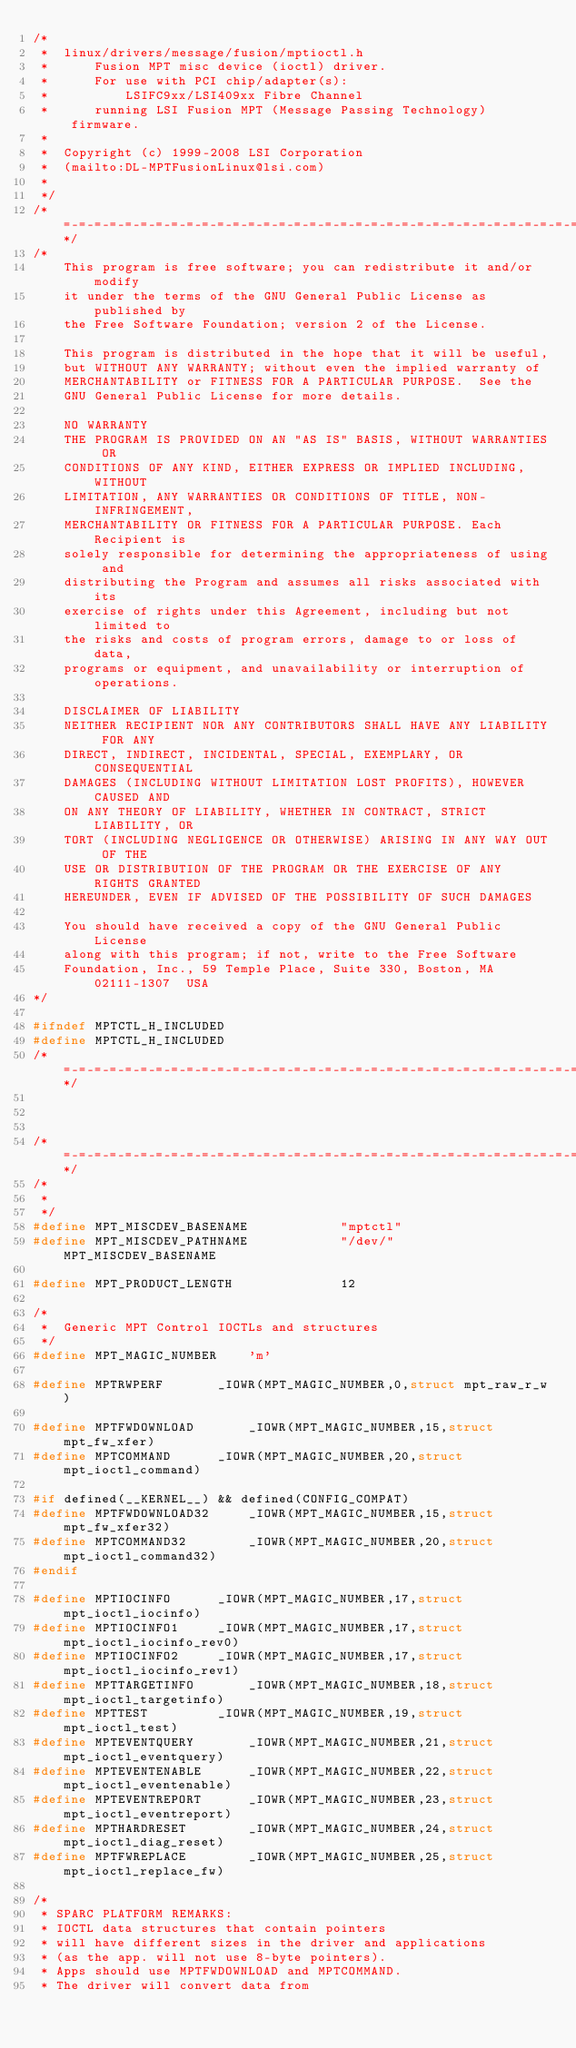<code> <loc_0><loc_0><loc_500><loc_500><_C_>/*
 *  linux/drivers/message/fusion/mptioctl.h
 *      Fusion MPT misc device (ioctl) driver.
 *      For use with PCI chip/adapter(s):
 *          LSIFC9xx/LSI409xx Fibre Channel
 *      running LSI Fusion MPT (Message Passing Technology) firmware.
 *
 *  Copyright (c) 1999-2008 LSI Corporation
 *  (mailto:DL-MPTFusionLinux@lsi.com)
 *
 */
/*=-=-=-=-=-=-=-=-=-=-=-=-=-=-=-=-=-=-=-=-=-=-=-=-=-=-=-=-=-=-=-=-=-=-=-=-=-=*/
/*
    This program is free software; you can redistribute it and/or modify
    it under the terms of the GNU General Public License as published by
    the Free Software Foundation; version 2 of the License.

    This program is distributed in the hope that it will be useful,
    but WITHOUT ANY WARRANTY; without even the implied warranty of
    MERCHANTABILITY or FITNESS FOR A PARTICULAR PURPOSE.  See the
    GNU General Public License for more details.

    NO WARRANTY
    THE PROGRAM IS PROVIDED ON AN "AS IS" BASIS, WITHOUT WARRANTIES OR
    CONDITIONS OF ANY KIND, EITHER EXPRESS OR IMPLIED INCLUDING, WITHOUT
    LIMITATION, ANY WARRANTIES OR CONDITIONS OF TITLE, NON-INFRINGEMENT,
    MERCHANTABILITY OR FITNESS FOR A PARTICULAR PURPOSE. Each Recipient is
    solely responsible for determining the appropriateness of using and
    distributing the Program and assumes all risks associated with its
    exercise of rights under this Agreement, including but not limited to
    the risks and costs of program errors, damage to or loss of data,
    programs or equipment, and unavailability or interruption of operations.

    DISCLAIMER OF LIABILITY
    NEITHER RECIPIENT NOR ANY CONTRIBUTORS SHALL HAVE ANY LIABILITY FOR ANY
    DIRECT, INDIRECT, INCIDENTAL, SPECIAL, EXEMPLARY, OR CONSEQUENTIAL
    DAMAGES (INCLUDING WITHOUT LIMITATION LOST PROFITS), HOWEVER CAUSED AND
    ON ANY THEORY OF LIABILITY, WHETHER IN CONTRACT, STRICT LIABILITY, OR
    TORT (INCLUDING NEGLIGENCE OR OTHERWISE) ARISING IN ANY WAY OUT OF THE
    USE OR DISTRIBUTION OF THE PROGRAM OR THE EXERCISE OF ANY RIGHTS GRANTED
    HEREUNDER, EVEN IF ADVISED OF THE POSSIBILITY OF SUCH DAMAGES

    You should have received a copy of the GNU General Public License
    along with this program; if not, write to the Free Software
    Foundation, Inc., 59 Temple Place, Suite 330, Boston, MA  02111-1307  USA
*/

#ifndef MPTCTL_H_INCLUDED
#define MPTCTL_H_INCLUDED
/*=-=-=-=-=-=-=-=-=-=-=-=-=-=-=-=-=-=-=-=-=-=-=-=-=-=-=-=-=-=-=-=-=-=-=-=-=-=*/



/*=-=-=-=-=-=-=-=-=-=-=-=-=-=-=-=-=-=-=-=-=-=-=-=-=-=-=-=-=-=-=-=-=-=-=-=-=-=*/
/*
 *
 */
#define MPT_MISCDEV_BASENAME            "mptctl"
#define MPT_MISCDEV_PATHNAME            "/dev/" MPT_MISCDEV_BASENAME

#define MPT_PRODUCT_LENGTH              12

/*
 *  Generic MPT Control IOCTLs and structures
 */
#define MPT_MAGIC_NUMBER	'm'

#define MPTRWPERF		_IOWR(MPT_MAGIC_NUMBER,0,struct mpt_raw_r_w)

#define MPTFWDOWNLOAD		_IOWR(MPT_MAGIC_NUMBER,15,struct mpt_fw_xfer)
#define MPTCOMMAND		_IOWR(MPT_MAGIC_NUMBER,20,struct mpt_ioctl_command)

#if defined(__KERNEL__) && defined(CONFIG_COMPAT)
#define MPTFWDOWNLOAD32		_IOWR(MPT_MAGIC_NUMBER,15,struct mpt_fw_xfer32)
#define MPTCOMMAND32		_IOWR(MPT_MAGIC_NUMBER,20,struct mpt_ioctl_command32)
#endif

#define MPTIOCINFO		_IOWR(MPT_MAGIC_NUMBER,17,struct mpt_ioctl_iocinfo)
#define MPTIOCINFO1		_IOWR(MPT_MAGIC_NUMBER,17,struct mpt_ioctl_iocinfo_rev0)
#define MPTIOCINFO2		_IOWR(MPT_MAGIC_NUMBER,17,struct mpt_ioctl_iocinfo_rev1)
#define MPTTARGETINFO		_IOWR(MPT_MAGIC_NUMBER,18,struct mpt_ioctl_targetinfo)
#define MPTTEST			_IOWR(MPT_MAGIC_NUMBER,19,struct mpt_ioctl_test)
#define MPTEVENTQUERY		_IOWR(MPT_MAGIC_NUMBER,21,struct mpt_ioctl_eventquery)
#define MPTEVENTENABLE		_IOWR(MPT_MAGIC_NUMBER,22,struct mpt_ioctl_eventenable)
#define MPTEVENTREPORT		_IOWR(MPT_MAGIC_NUMBER,23,struct mpt_ioctl_eventreport)
#define MPTHARDRESET		_IOWR(MPT_MAGIC_NUMBER,24,struct mpt_ioctl_diag_reset)
#define MPTFWREPLACE		_IOWR(MPT_MAGIC_NUMBER,25,struct mpt_ioctl_replace_fw)

/*
 * SPARC PLATFORM REMARKS:
 * IOCTL data structures that contain pointers
 * will have different sizes in the driver and applications
 * (as the app. will not use 8-byte pointers).
 * Apps should use MPTFWDOWNLOAD and MPTCOMMAND.
 * The driver will convert data from</code> 